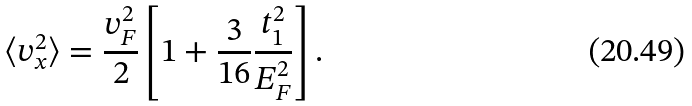<formula> <loc_0><loc_0><loc_500><loc_500>\langle v _ { x } ^ { 2 } \rangle = \frac { v _ { F } ^ { 2 } } { 2 } \left [ 1 + \frac { 3 } { 1 6 } \frac { t _ { 1 } ^ { 2 } } { E _ { F } ^ { 2 } } \right ] .</formula> 